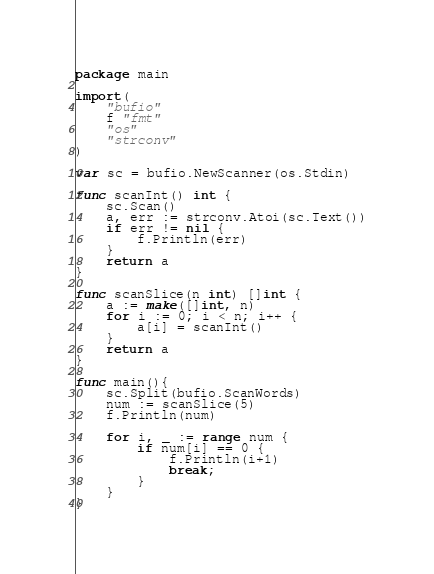<code> <loc_0><loc_0><loc_500><loc_500><_Go_>package main

import(
	"bufio"
	f "fmt"
	"os"
	"strconv"
)

var sc = bufio.NewScanner(os.Stdin)

func scanInt() int {
	sc.Scan()
	a, err := strconv.Atoi(sc.Text())
	if err != nil {
		f.Println(err)
	}
	return a
}

func scanSlice(n int) []int {
	a := make([]int, n)
	for i := 0; i < n; i++ {
		a[i] = scanInt()
	}
	return a
}

func main(){
	sc.Split(bufio.ScanWords)
	num := scanSlice(5)
	f.Println(num)

	for i, _ := range num {
		if num[i] == 0 {
			f.Println(i+1)
			break;
		}
	}
}</code> 